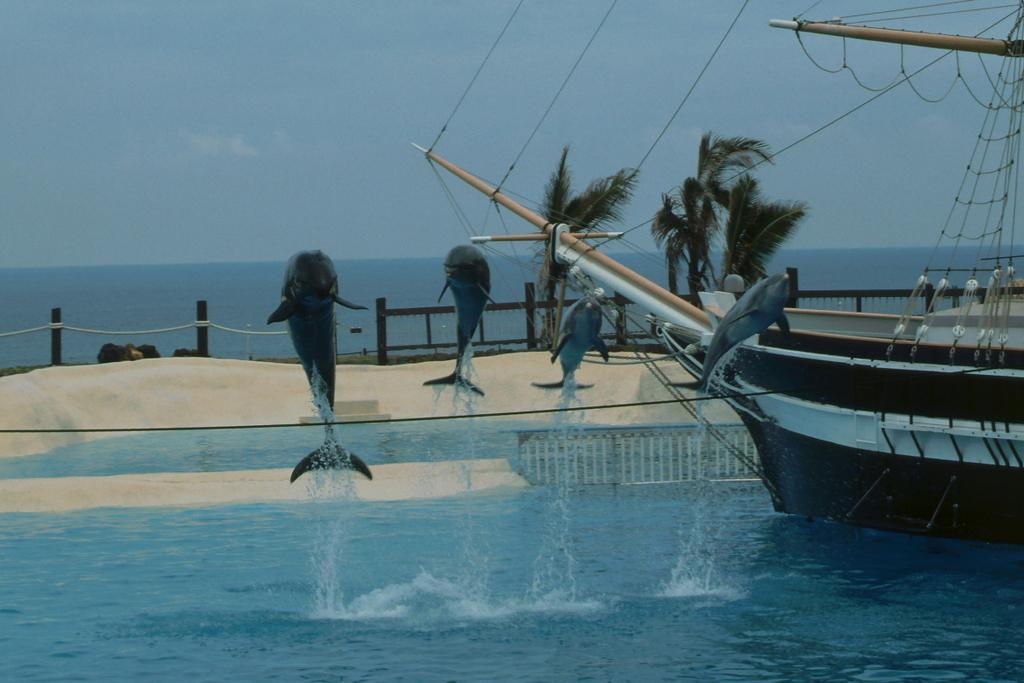What animals are in the center of the image? There are dolphins in the center of the image. What type of environment is depicted in the image? There is water visible at the bottom of the image, suggesting a marine or coastal setting. What other objects or structures can be seen in the image? There is a ship on the water on the right side of the image, a fence in the background, and trees and the sky are visible in the background as well. Where is the father standing in the image? There is no father present in the image; it features dolphins, water, a ship, a fence, trees, and the sky. What type of mailbox can be seen near the trees in the image? There is no mailbox present in the image; it features dolphins, water, a ship, a fence, trees, and the sky. 